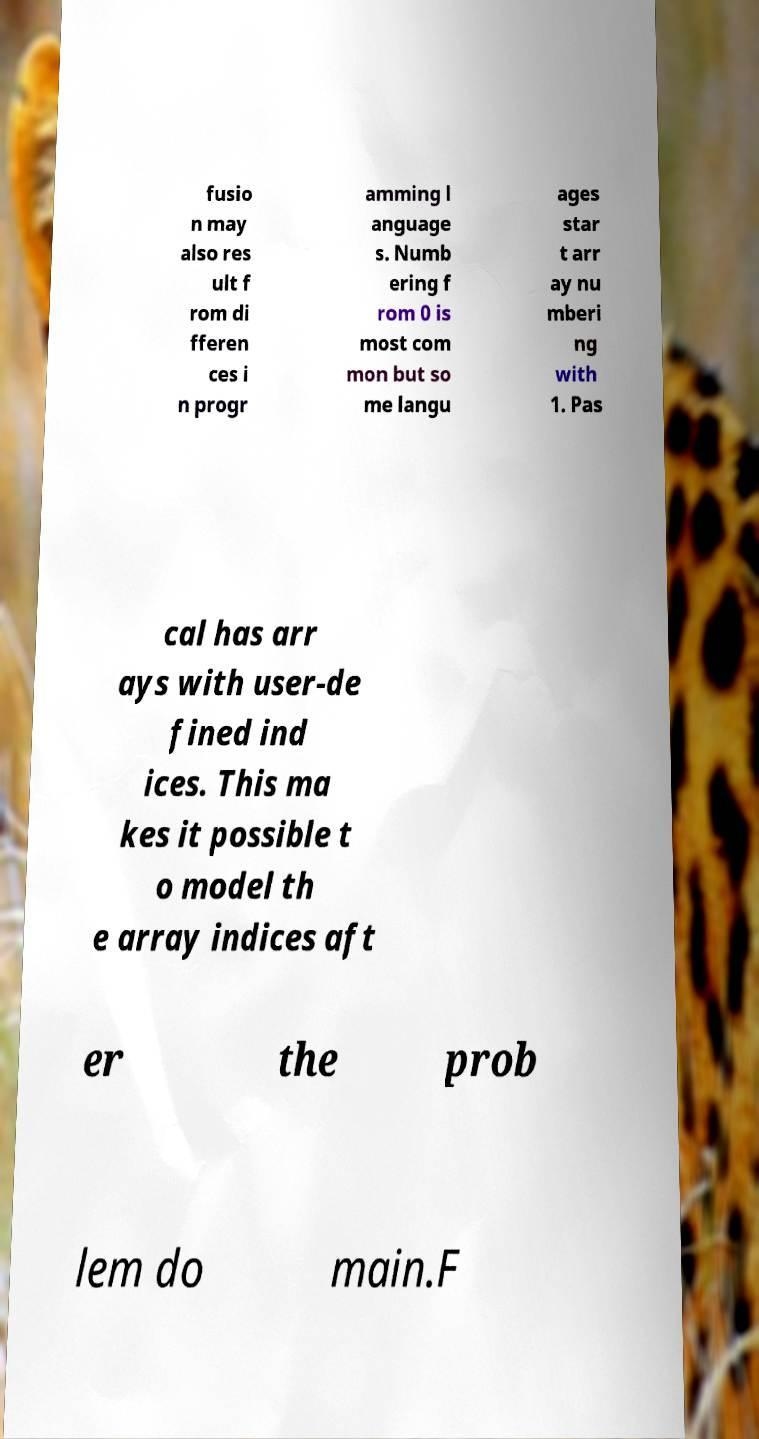Please read and relay the text visible in this image. What does it say? fusio n may also res ult f rom di fferen ces i n progr amming l anguage s. Numb ering f rom 0 is most com mon but so me langu ages star t arr ay nu mberi ng with 1. Pas cal has arr ays with user-de fined ind ices. This ma kes it possible t o model th e array indices aft er the prob lem do main.F 